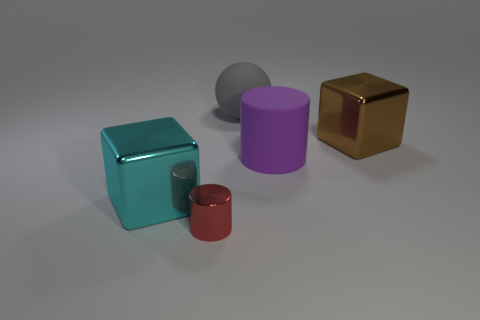Is there any other thing that has the same size as the red metal cylinder?
Make the answer very short. No. There is a gray ball that is the same material as the big purple cylinder; what size is it?
Your response must be concise. Large. What number of spheres are gray things or large things?
Offer a very short reply. 1. Are there more small green metal cylinders than metal things?
Give a very brief answer. No. What number of red shiny things are the same size as the red cylinder?
Provide a succinct answer. 0. What number of objects are cylinders that are to the right of the gray ball or big spheres?
Your answer should be very brief. 2. Is the number of big green matte things less than the number of brown blocks?
Offer a very short reply. Yes. What shape is the big thing that is made of the same material as the cyan cube?
Your answer should be compact. Cube. There is a brown cube; are there any big metal cubes in front of it?
Give a very brief answer. Yes. Are there fewer large shiny blocks that are left of the big purple thing than brown shiny blocks?
Your response must be concise. No. 